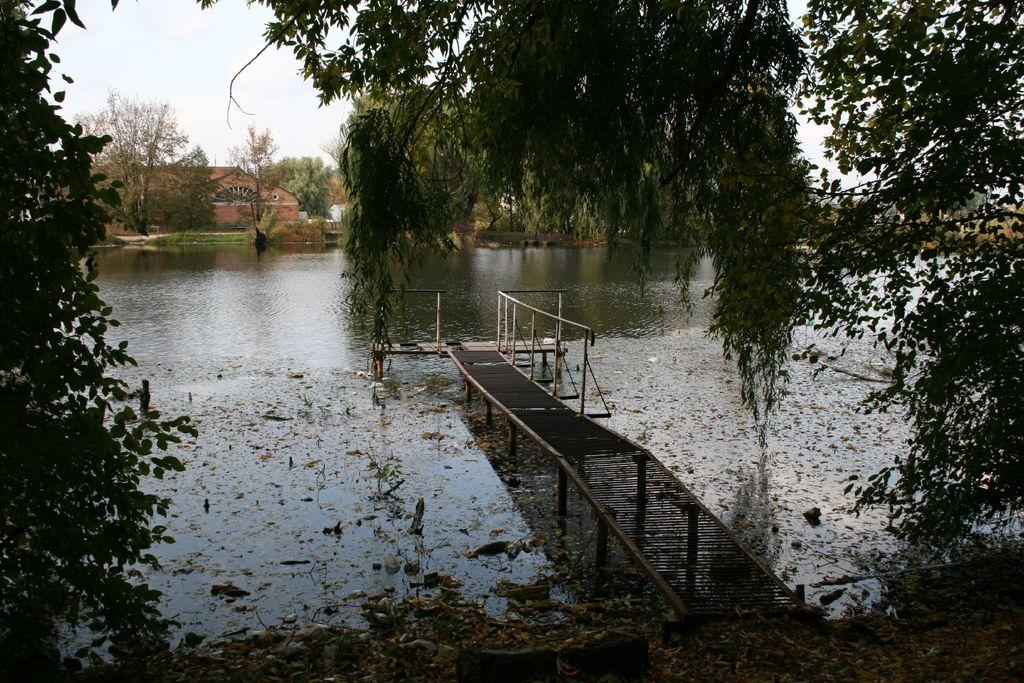What type of structure is in the image? There is a walkway bridge in the image. What can be found on the ground in the image? Shredded leaves are present in the image. What type of vegetation is in the image? There are trees in the image. What body of water is in the image? There is a lake in the image. What type of man-made structures are in the image? Buildings are visible in the image. What part of the natural environment is visible in the image? The sky is visible in the image. What type of drug can be seen in the image? There is no drug present in the image. What type of horn is visible on the trees in the image? There are no horns visible on the trees in the image. 